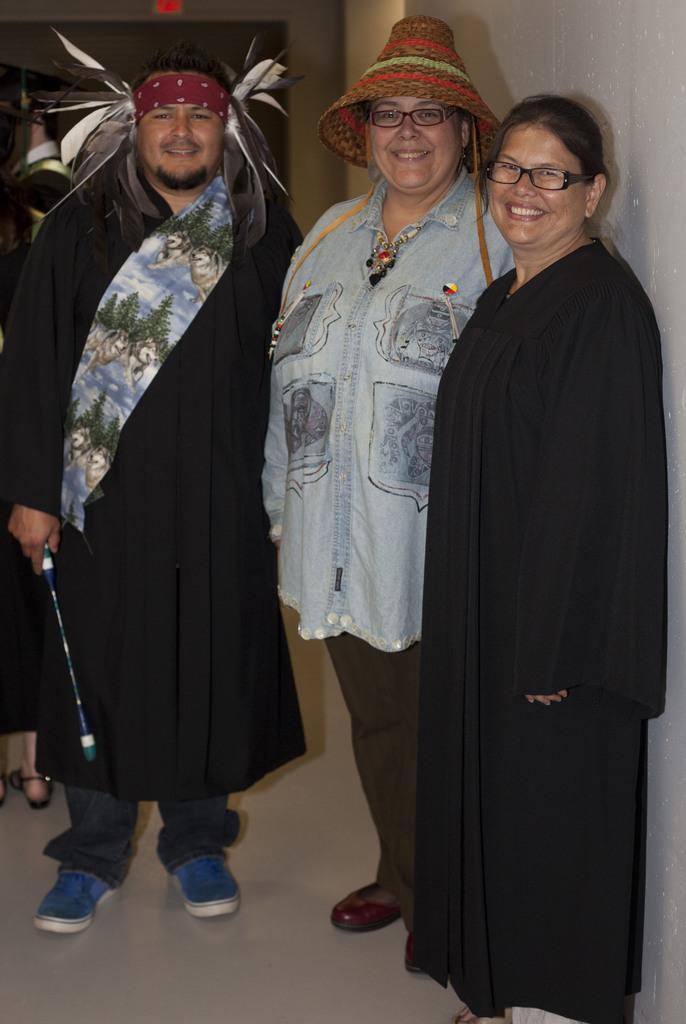How many people are in the image? There are persons in the image. What is one person doing in the image? One person is holding an object. What can be seen in the background of the image? There is a wall in the background of the image. What type of letters can be seen in the eyes of the person in the image? There are no letters visible in the eyes of the person in the image. 